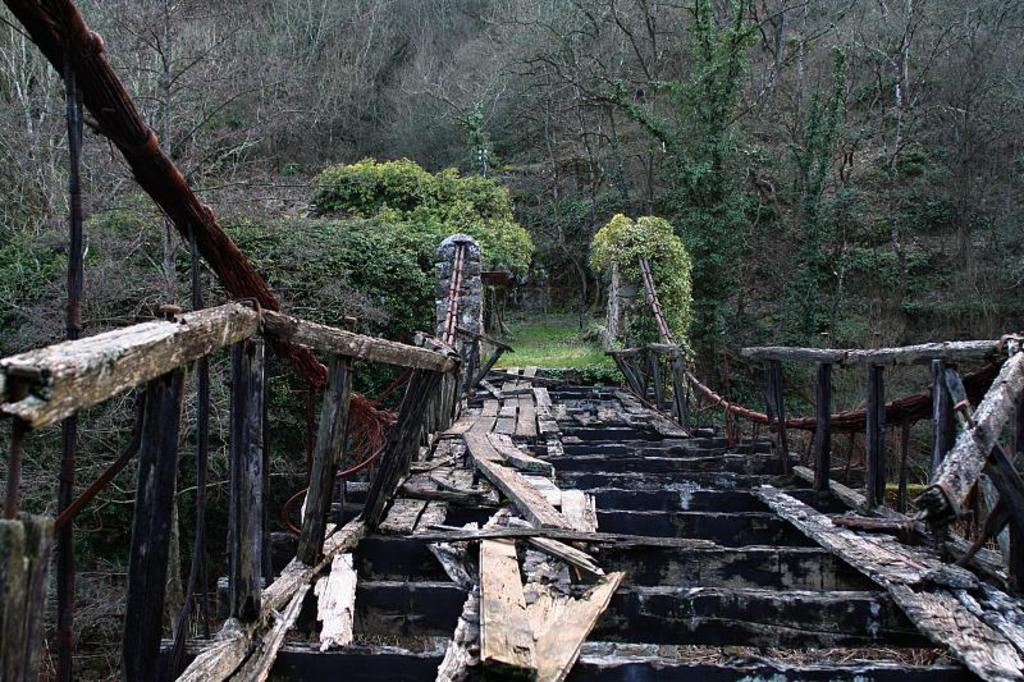What is the main subject in the foreground of the image? There is a broken bridge in the foreground of the image. How would you describe the condition of the bridge? The bridge is broken. What can be seen in the background of the image? There are trees visible in the background of the image. What type of store can be seen near the broken bridge in the image? There is no store present in the image; it only features a broken bridge and trees in the background. 